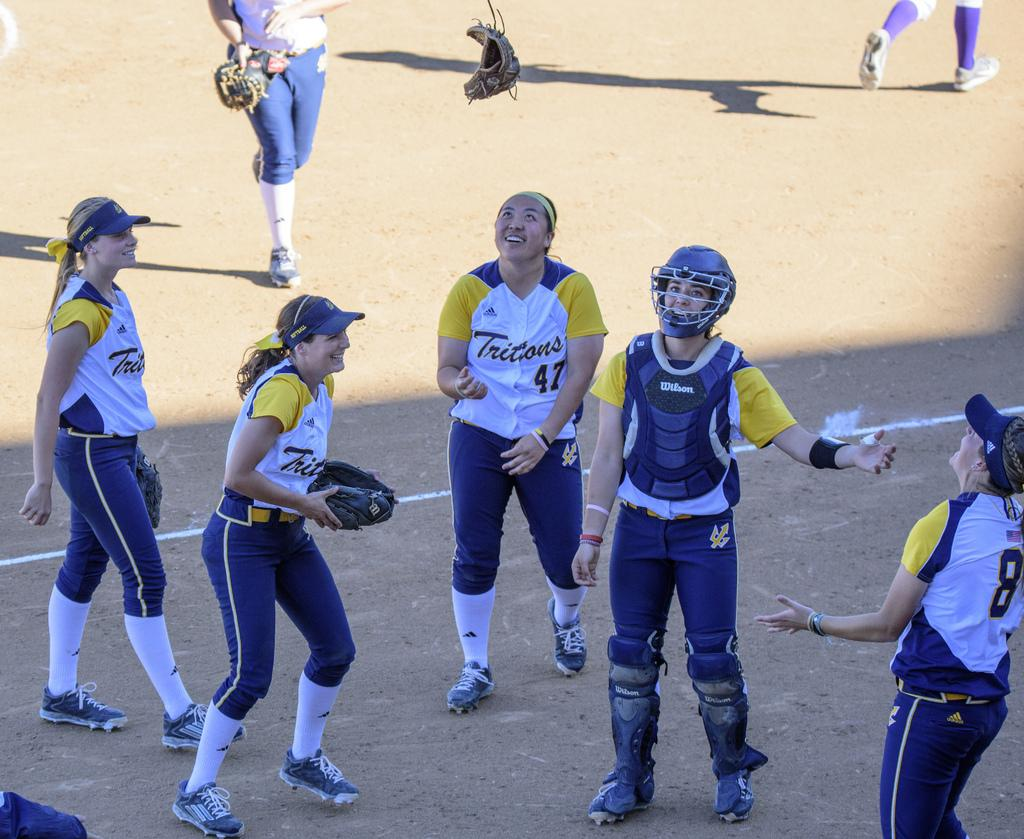<image>
Write a terse but informative summary of the picture. Softball players for the Tritons laugh as #47 and #8 look up at a glove that has been thrown in the air. 